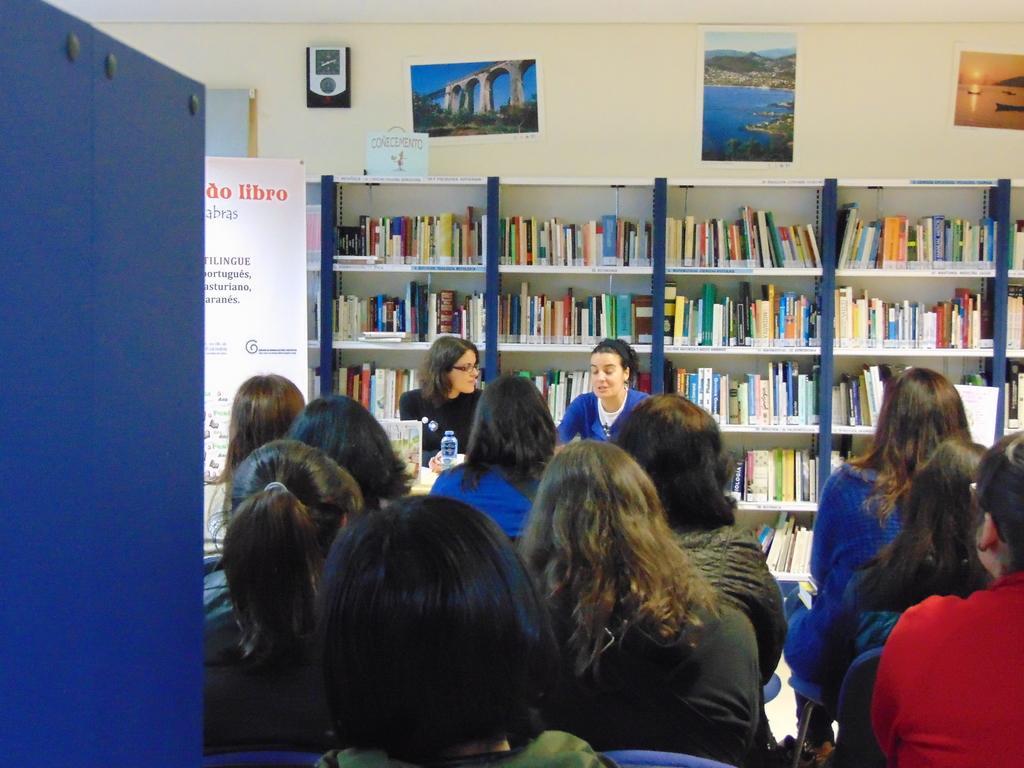Can you describe this image briefly? In this image I can see a group of people are sitting on the chairs in front of a table. In the background I can see a cupboard in which books are there, board, wall and wall paintings. This image is taken in a hall. 